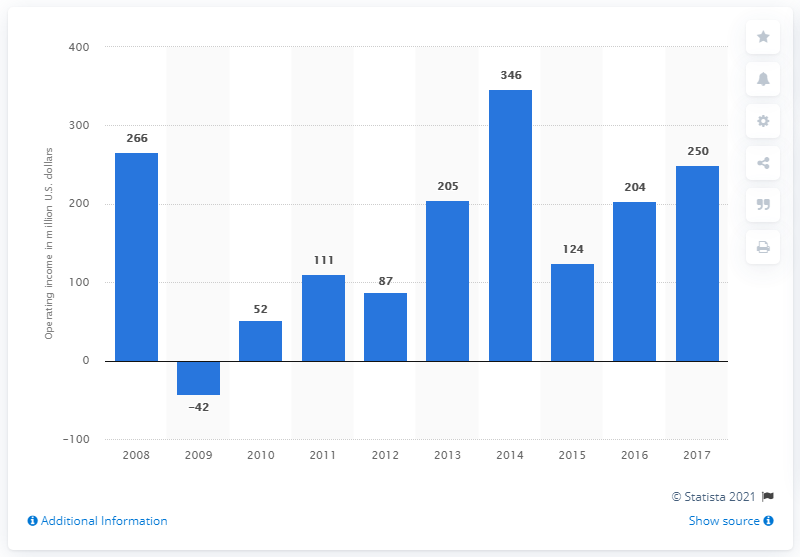Identify some key points in this picture. In 2017, the operating income of Hyatt Hotels Corporation was approximately $250 million in U.S. dollars. 